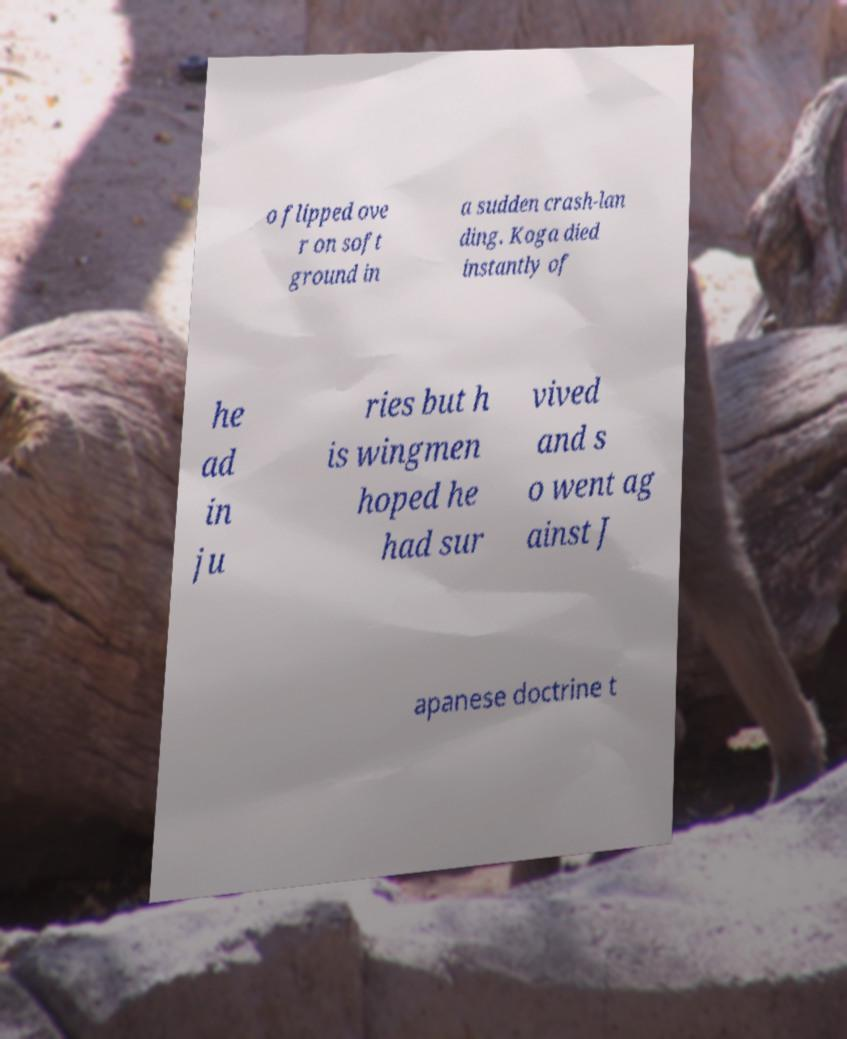Could you extract and type out the text from this image? o flipped ove r on soft ground in a sudden crash-lan ding. Koga died instantly of he ad in ju ries but h is wingmen hoped he had sur vived and s o went ag ainst J apanese doctrine t 